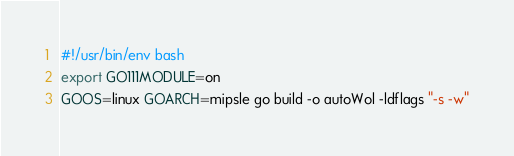<code> <loc_0><loc_0><loc_500><loc_500><_Bash_>#!/usr/bin/env bash
export GO111MODULE=on
GOOS=linux GOARCH=mipsle go build -o autoWol -ldflags "-s -w"</code> 